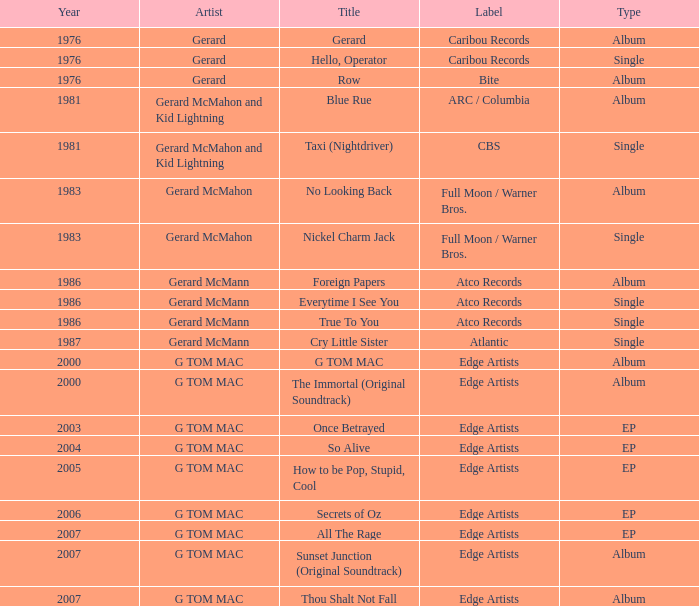Which Title has a Type of ep and a Year larger than 2003? So Alive, How to be Pop, Stupid, Cool, Secrets of Oz, All The Rage. 